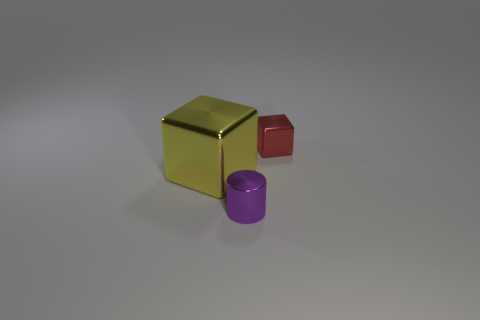Add 3 purple shiny things. How many objects exist? 6 Subtract all red blocks. How many blocks are left? 1 Subtract 1 blocks. How many blocks are left? 1 Subtract all cylinders. How many objects are left? 2 Add 3 cylinders. How many cylinders are left? 4 Add 1 tiny green spheres. How many tiny green spheres exist? 1 Subtract 0 cyan spheres. How many objects are left? 3 Subtract all yellow blocks. Subtract all red cylinders. How many blocks are left? 1 Subtract all red cylinders. How many yellow cubes are left? 1 Subtract all tiny red shiny cubes. Subtract all red cubes. How many objects are left? 1 